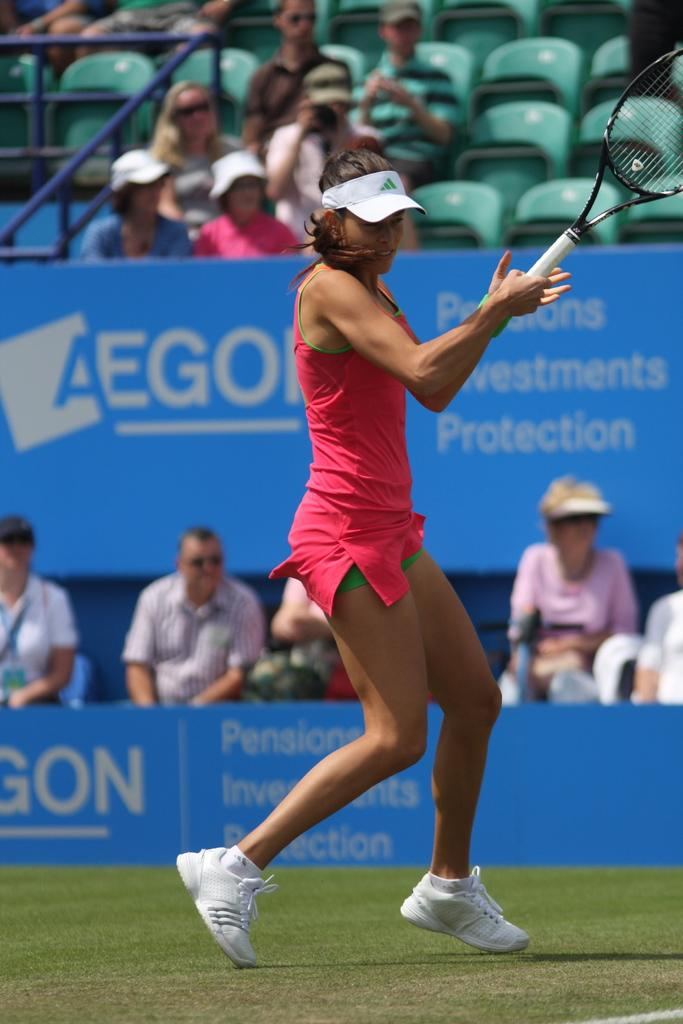Who is the main subject in the image? There is a woman in the image. What is the woman holding in the image? The woman is holding a racket. Can you describe the background of the image? There are people sitting on chairs in the background of the image. What type of home can be seen in the background of the image? There is no home visible in the background of the image; it only shows people sitting on chairs. 